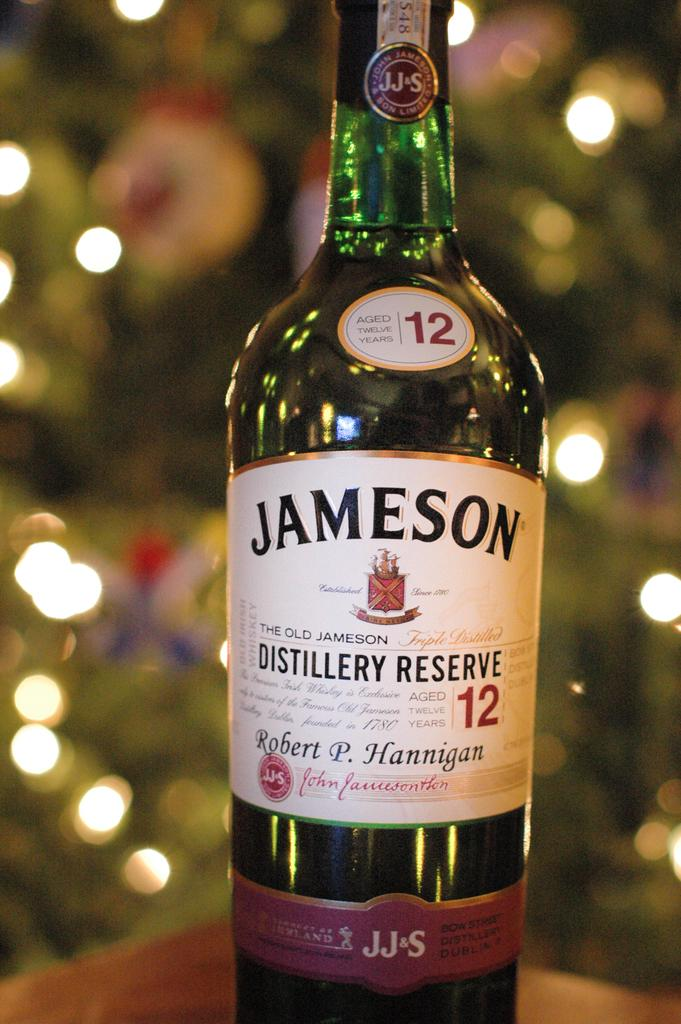<image>
Render a clear and concise summary of the photo. A bottle of Jameson aged 12 years sits in front of a lighted background. 